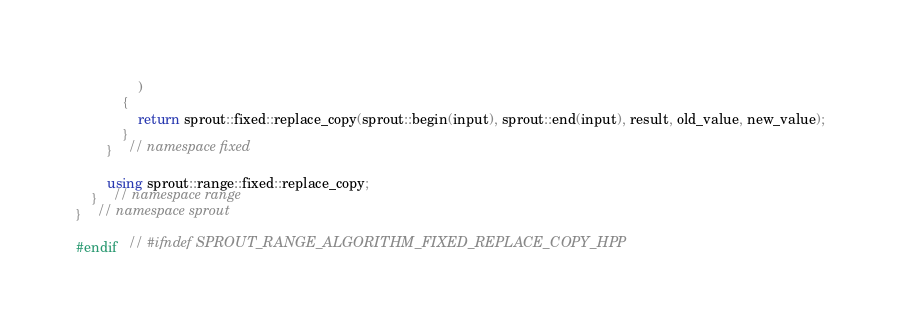Convert code to text. <code><loc_0><loc_0><loc_500><loc_500><_C++_>				)
			{
				return sprout::fixed::replace_copy(sprout::begin(input), sprout::end(input), result, old_value, new_value);
			}
		}	// namespace fixed

		using sprout::range::fixed::replace_copy;
	}	// namespace range
}	// namespace sprout

#endif	// #ifndef SPROUT_RANGE_ALGORITHM_FIXED_REPLACE_COPY_HPP
</code> 